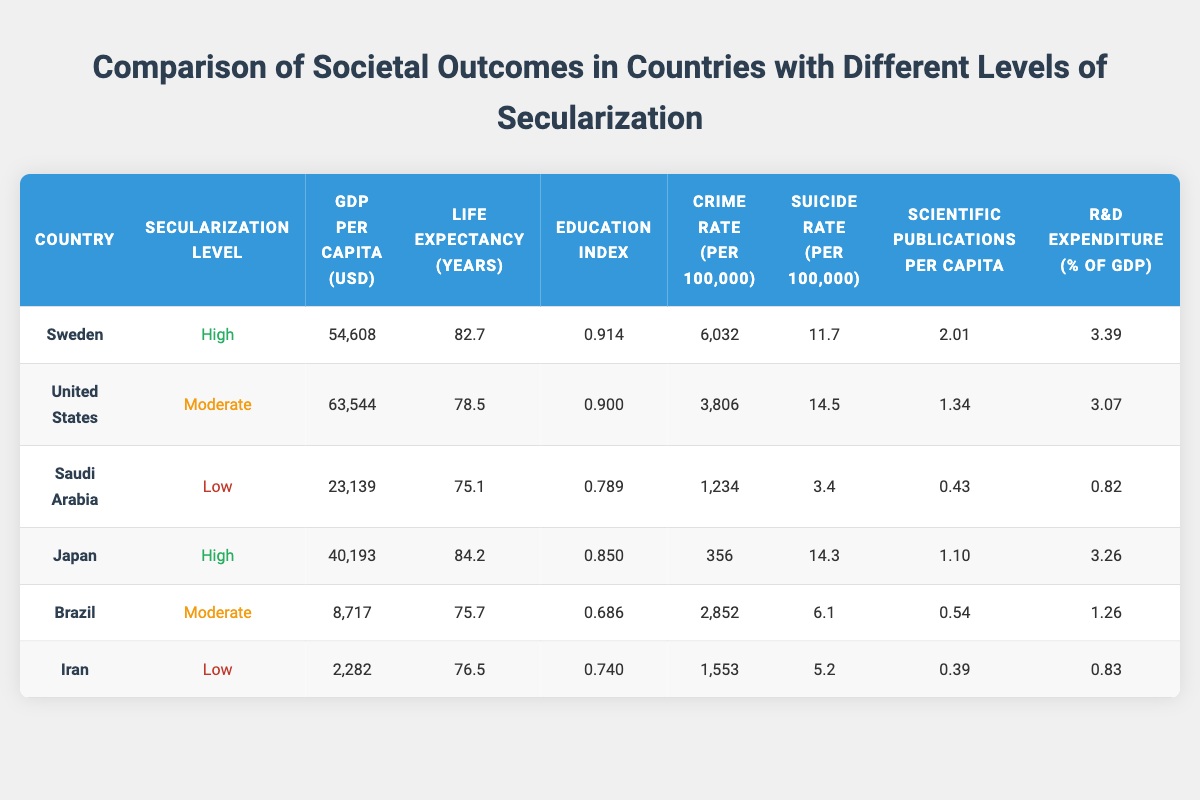What is the GDP per capita of Sweden? The table shows the GDP per capita of Sweden listed as 54,608 USD.
Answer: 54,608 USD Is the life expectancy in the United States higher than in Brazil? The life expectancy in the United States is 78.5 years, while in Brazil it is 75.7 years; since 78.5 is greater than 75.7, the answer is yes.
Answer: Yes Which country has the highest education index? By reviewing the education index column, Sweden has the highest education index of 0.914 compared to other countries listed.
Answer: Sweden What is the average GDP per capita of countries with high secularization? The GDP per capita for Sweden is 54,608 USD and for Japan it is 40,193 USD; adding these gives 94,801 USD. Dividing by 2 (the number of countries) gives an average of 47,400.5 USD.
Answer: 47,400.5 USD Is the suicide rate in Saudi Arabia lower than in Iran? The table indicates that the suicide rate in Saudi Arabia is 3.4 per 100,000 while in Iran it is 5.2 per 100,000. Since 3.4 is less than 5.2, the answer is yes.
Answer: Yes What is the difference in crime rates between the United States and Japan? The crime rate for the United States is 3,806 per 100,000 and for Japan it is 356 per 100,000. The difference is calculated by subtracting Japan's crime rate from the United States', which results in 3,806 - 356 = 3,450.
Answer: 3,450 How many scientific publications per capita does Iran have compared to Sweden? Iran has 0.39 scientific publications per capita and Sweden has 2.01 publications. To find out how many more Sweden has, subtract Iran's figure from Sweden's: 2.01 - 0.39 = 1.62, indicating Sweden has 1.62 more publications per capita than Iran.
Answer: 1.62 Which country has the lowest R&D expenditure as a percentage of GDP? By examining the R&D expenditure column, Iran shows the lowest at 0.83% of GDP compared to other countries listed.
Answer: Iran What is the life expectancy of countries with moderate secularization? The United States has a life expectancy of 78.5 years and Brazil has 75.7 years; to find the average, add these two values: 78.5 + 75.7 = 154.2, then divide by 2 to get 77.1 years.
Answer: 77.1 years 